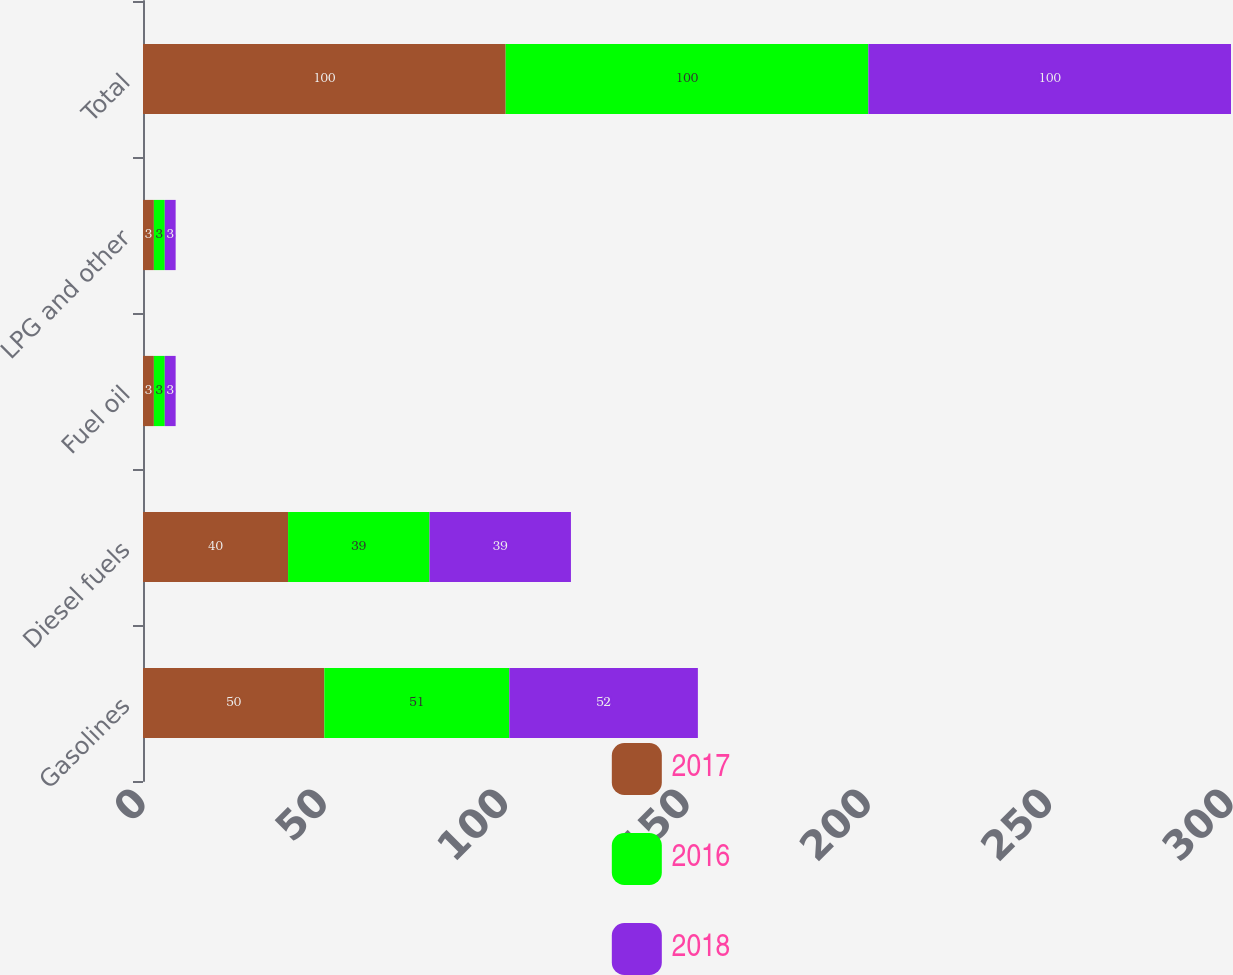Convert chart to OTSL. <chart><loc_0><loc_0><loc_500><loc_500><stacked_bar_chart><ecel><fcel>Gasolines<fcel>Diesel fuels<fcel>Fuel oil<fcel>LPG and other<fcel>Total<nl><fcel>2017<fcel>50<fcel>40<fcel>3<fcel>3<fcel>100<nl><fcel>2016<fcel>51<fcel>39<fcel>3<fcel>3<fcel>100<nl><fcel>2018<fcel>52<fcel>39<fcel>3<fcel>3<fcel>100<nl></chart> 